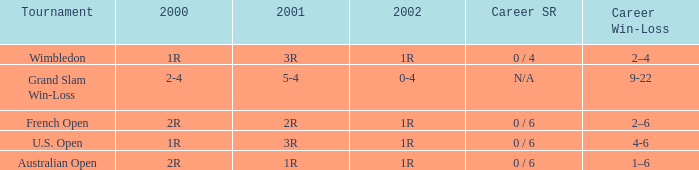Could you parse the entire table? {'header': ['Tournament', '2000', '2001', '2002', 'Career SR', 'Career Win-Loss'], 'rows': [['Wimbledon', '1R', '3R', '1R', '0 / 4', '2–4'], ['Grand Slam Win-Loss', '2-4', '5-4', '0-4', 'N/A', '9-22'], ['French Open', '2R', '2R', '1R', '0 / 6', '2–6'], ['U.S. Open', '1R', '3R', '1R', '0 / 6', '4-6'], ['Australian Open', '2R', '1R', '1R', '0 / 6', '1–6']]} In what year 2000 tournment did Angeles Montolio have a career win-loss record of 2-4? Grand Slam Win-Loss. 